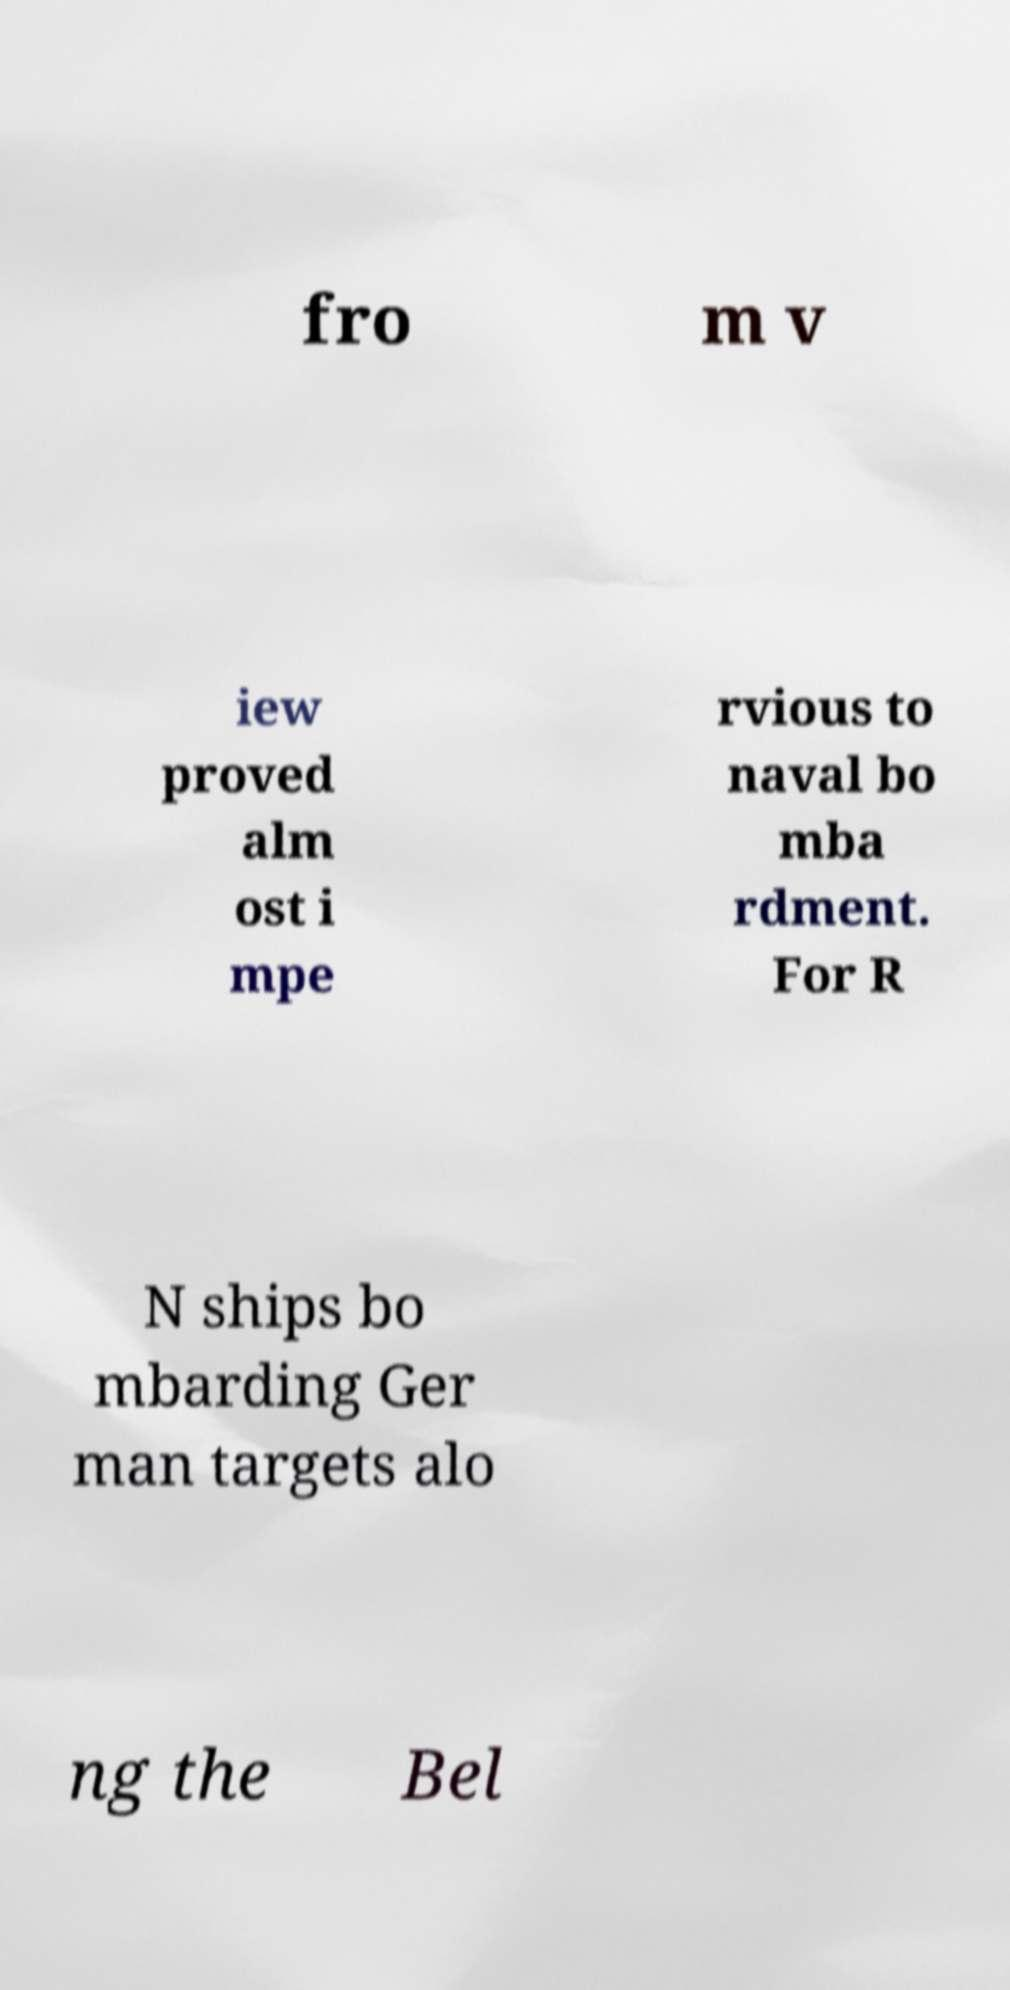Please identify and transcribe the text found in this image. fro m v iew proved alm ost i mpe rvious to naval bo mba rdment. For R N ships bo mbarding Ger man targets alo ng the Bel 